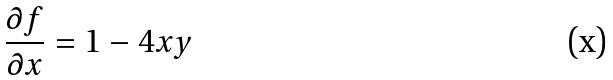Convert formula to latex. <formula><loc_0><loc_0><loc_500><loc_500>\frac { \partial f } { \partial x } = 1 - 4 x y</formula> 